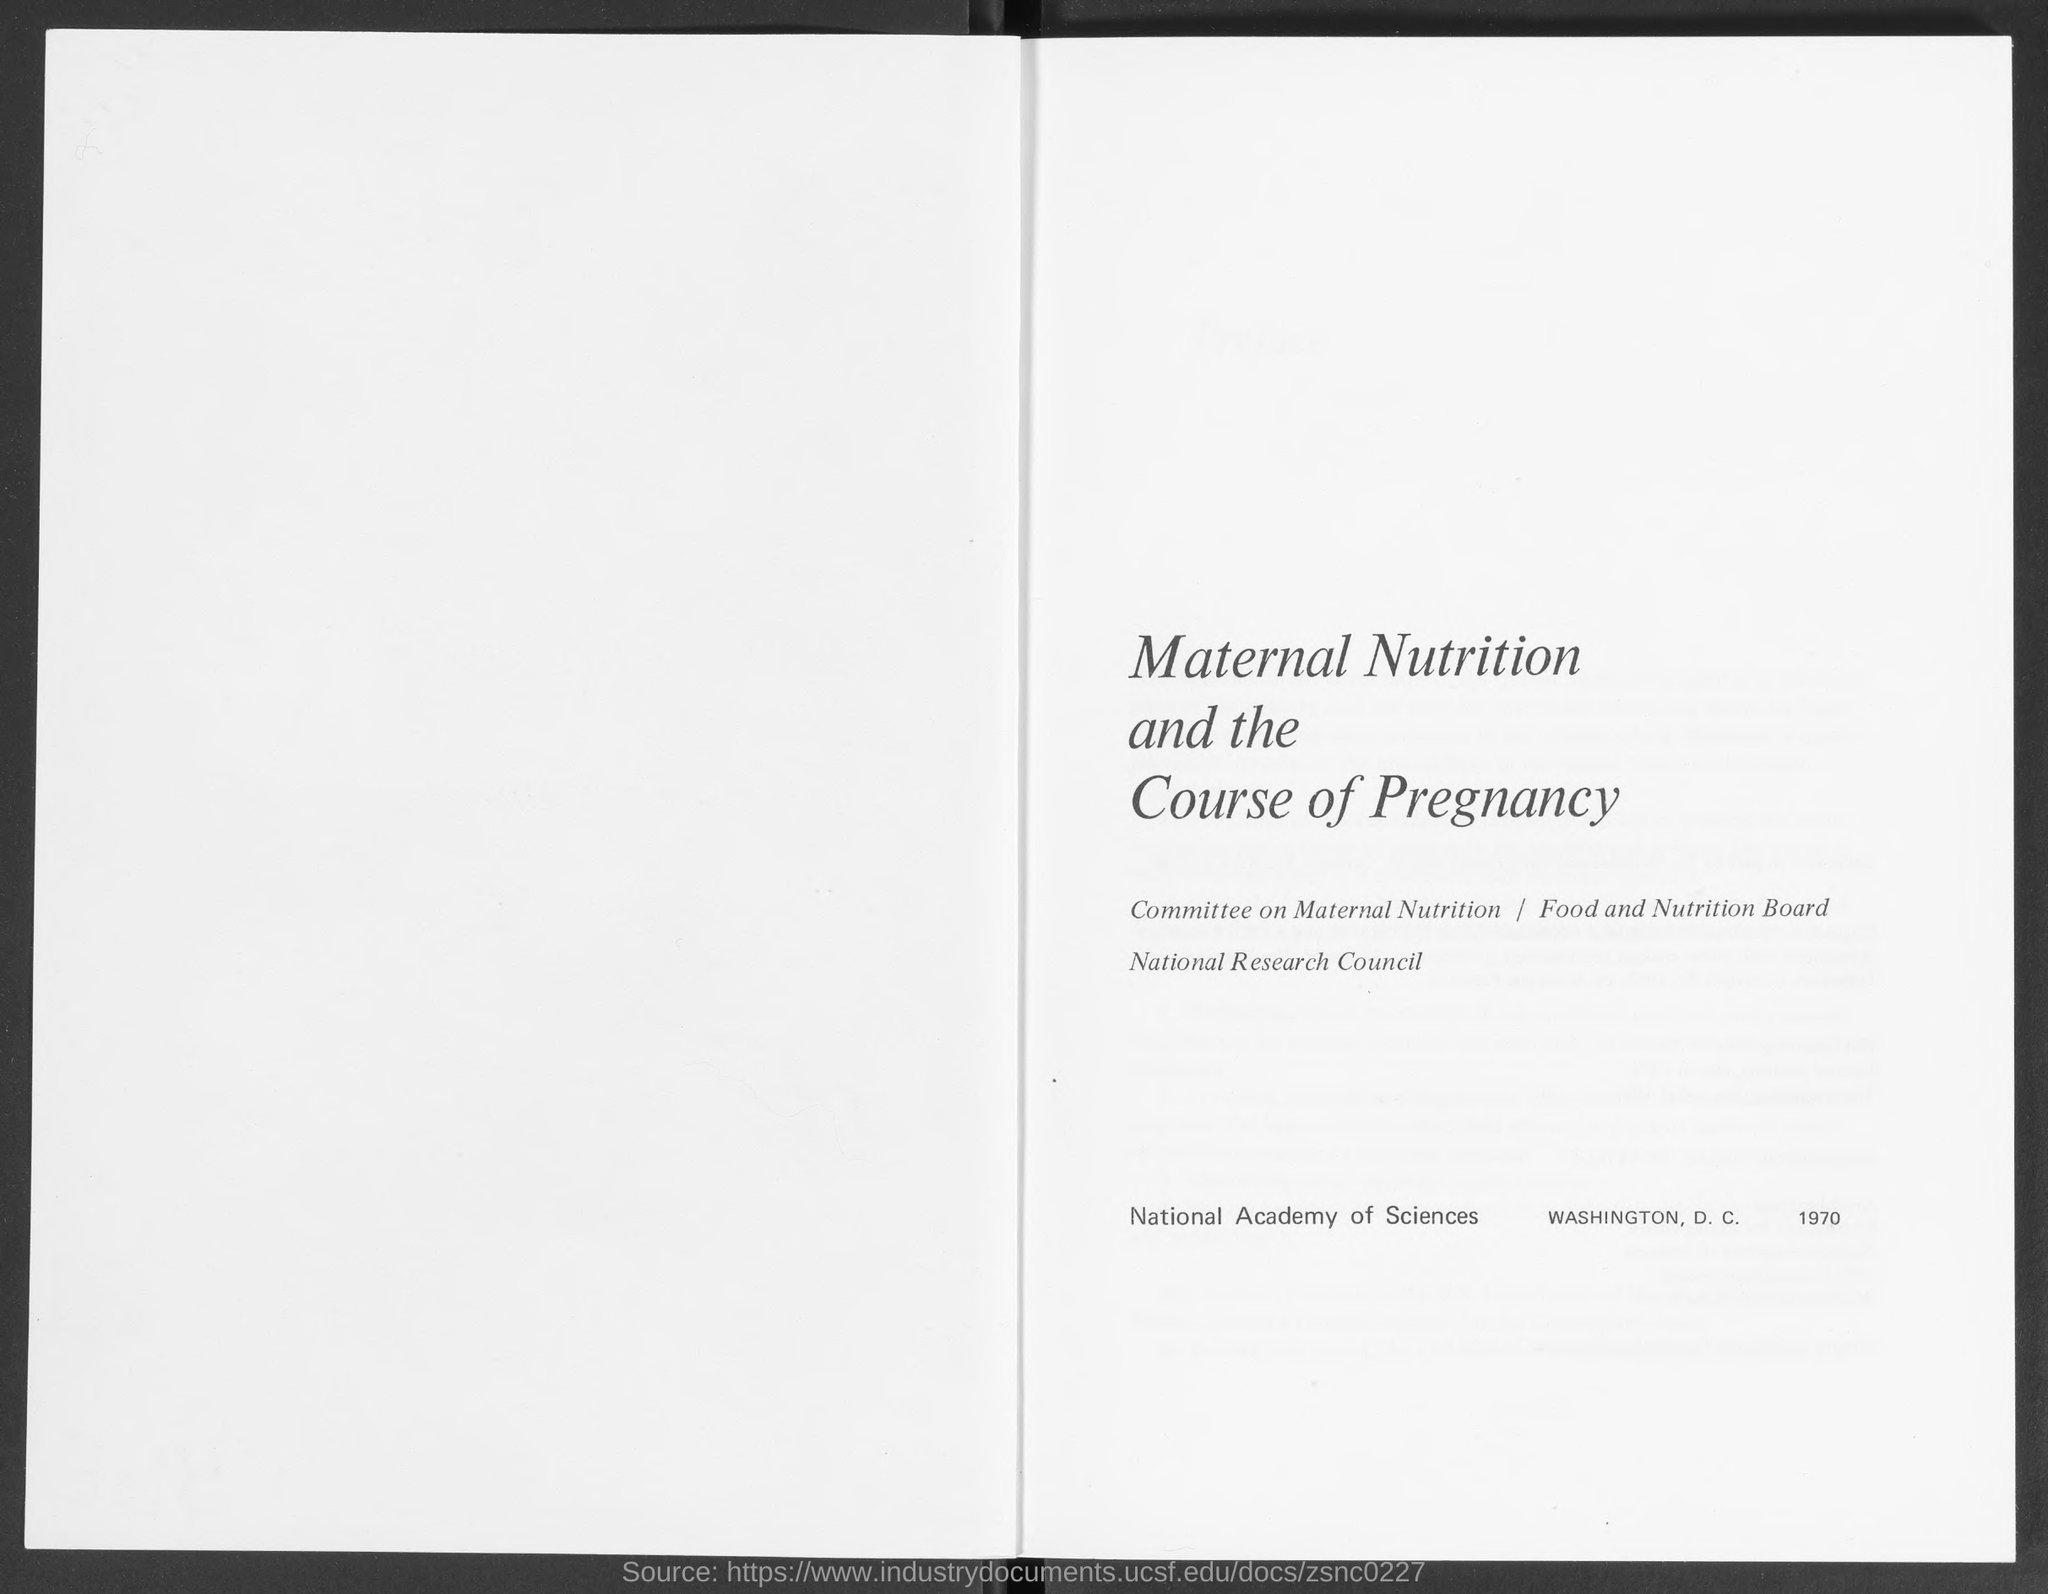Specify some key components in this picture. The heading on the given page is "Maternal Nutrition and the Course of Pregnancy. The National Research Council is the name of the council mentioned in the given page. The Committee on Maternal Nutrition is named in the provided page. 